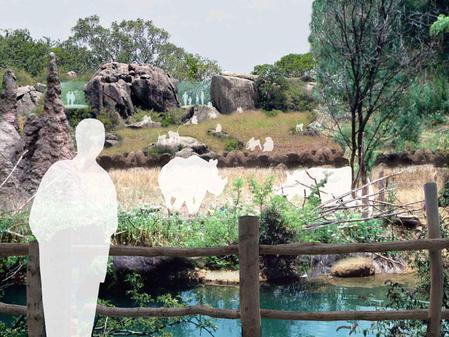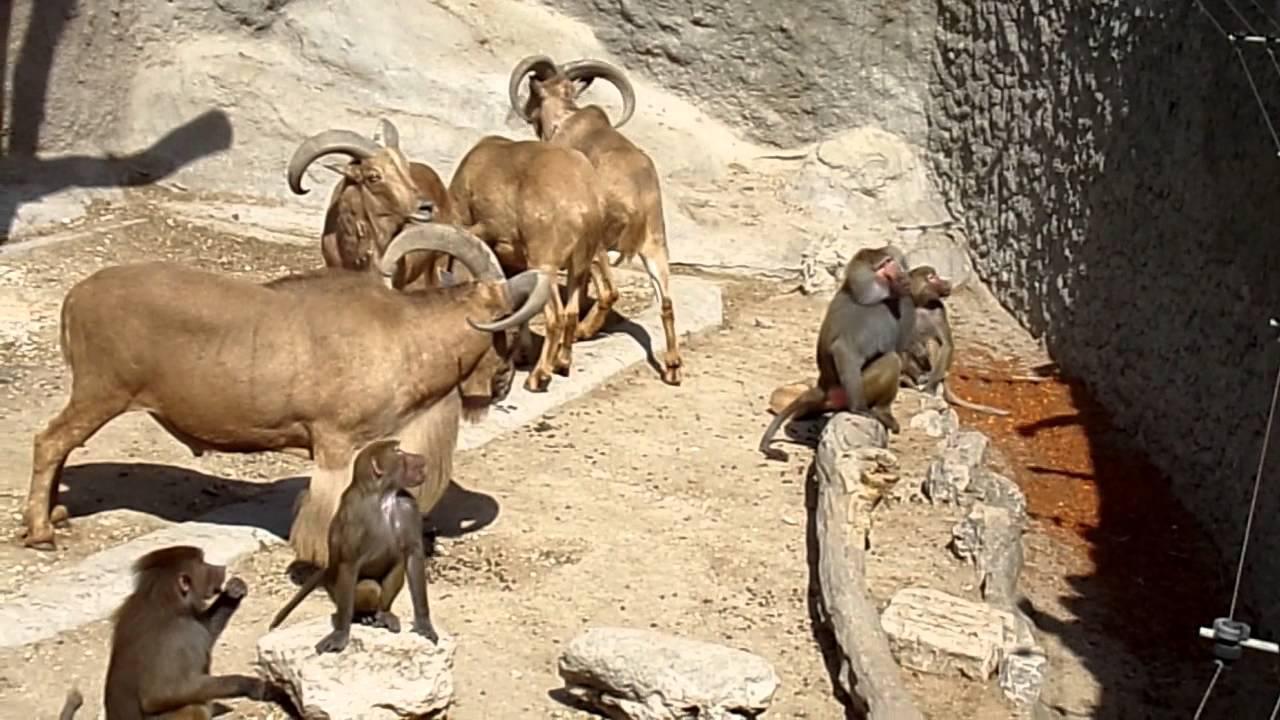The first image is the image on the left, the second image is the image on the right. For the images displayed, is the sentence "An image shows a horizontal row of no more than four baboons of the same size, crouching with some food." factually correct? Answer yes or no. No. 